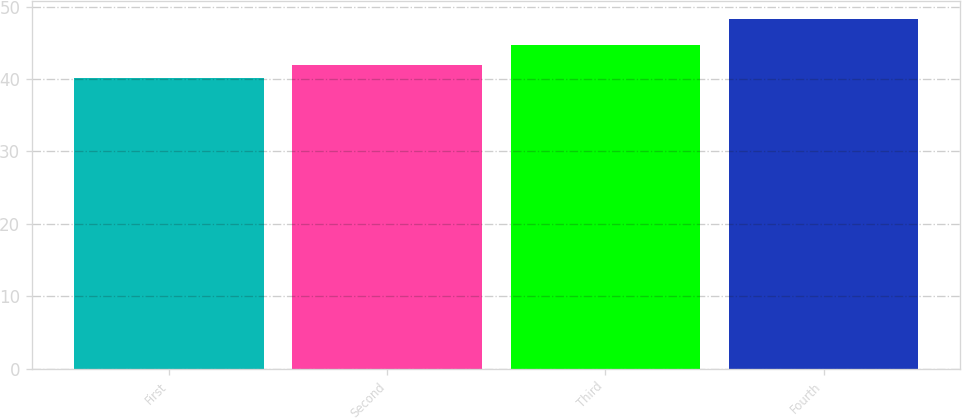<chart> <loc_0><loc_0><loc_500><loc_500><bar_chart><fcel>First<fcel>Second<fcel>Third<fcel>Fourth<nl><fcel>40.13<fcel>41.99<fcel>44.63<fcel>48.31<nl></chart> 